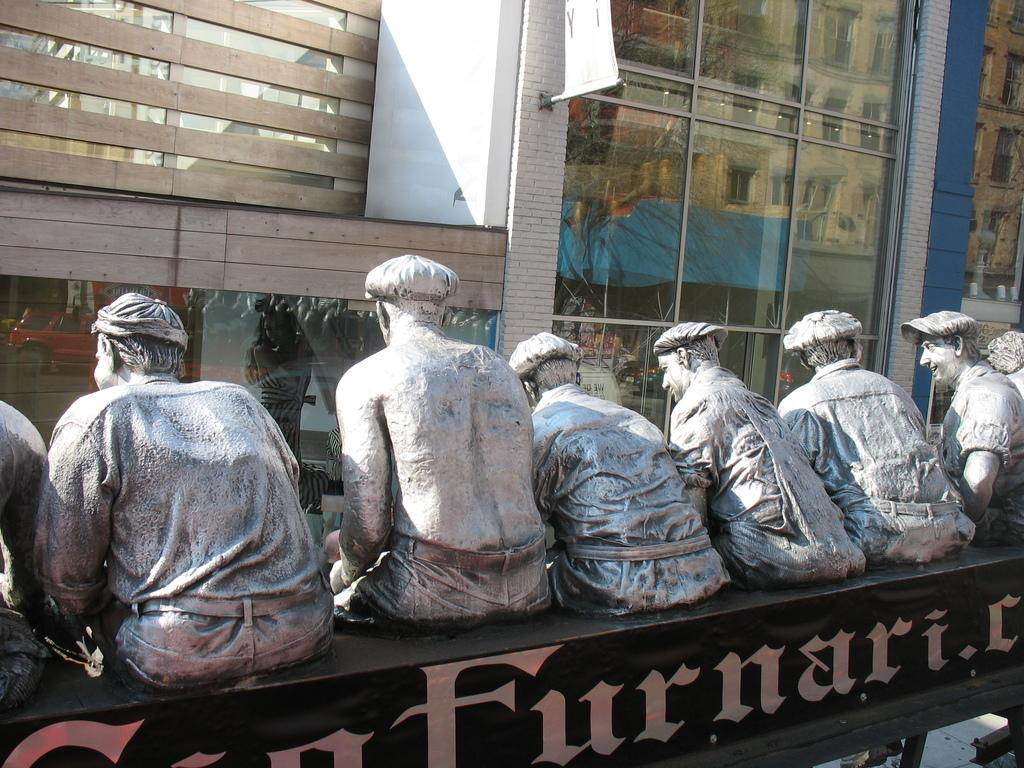What is the main subject of the image? There is a statue of people in the image. What can be seen on a black object in the image? There is something written on a black color object in the image. What type of structures can be seen in the background of the image? There are buildings in the background of the image. What architectural feature is present in the background of the image? There is a framed glass wall in the background of the image. What other objects can be seen in the background of the image? There are other objects visible in the background of the image. How many pages are visible in the image? There are no pages present in the image. What type of wave can be seen crashing on the shore in the image? There is no shore or wave present in the image. 